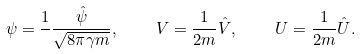<formula> <loc_0><loc_0><loc_500><loc_500>\psi = \frac { 1 } { } \frac { \hat { \psi } } { \sqrt { 8 \pi \gamma m } } , \quad V = \frac { 1 } { 2 m } \hat { V } , \quad U = \frac { 1 } { 2 m } \hat { U } .</formula> 